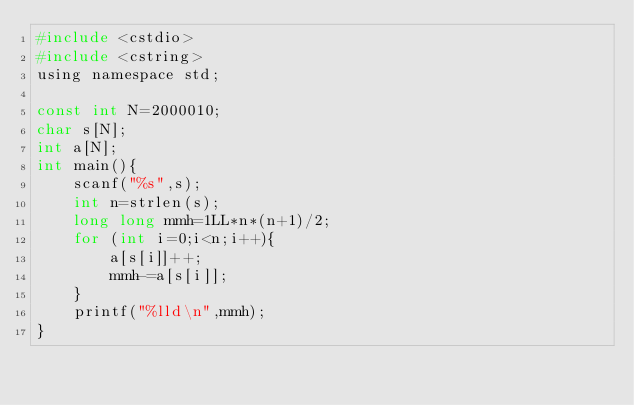<code> <loc_0><loc_0><loc_500><loc_500><_C_>#include <cstdio>
#include <cstring>
using namespace std;

const int N=2000010;
char s[N];
int a[N];
int main(){
    scanf("%s",s);
    int n=strlen(s);
    long long mmh=1LL*n*(n+1)/2;
    for (int i=0;i<n;i++){
    	a[s[i]]++;
    	mmh-=a[s[i]];
	}
    printf("%lld\n",mmh);
}</code> 